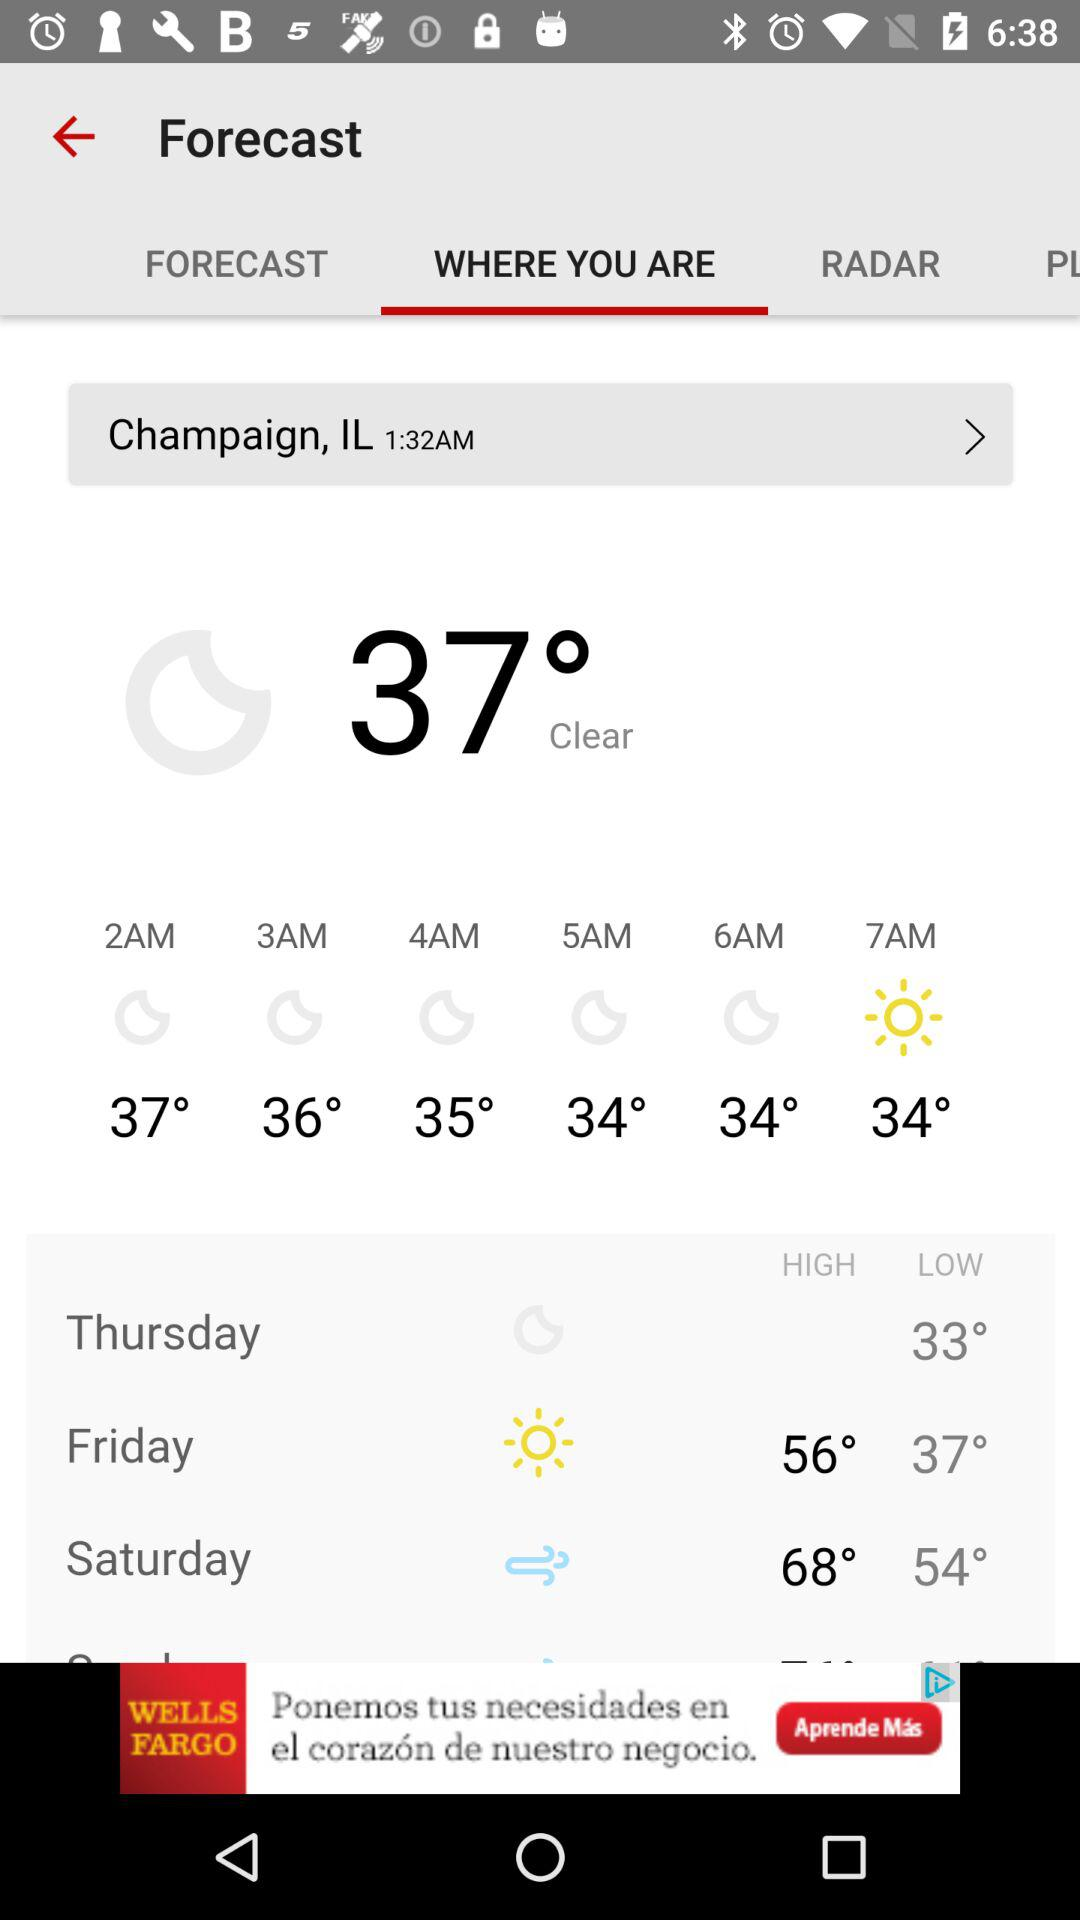What will the temperature be on Friday? The temperature on Friday will range from 37° to 56°. 